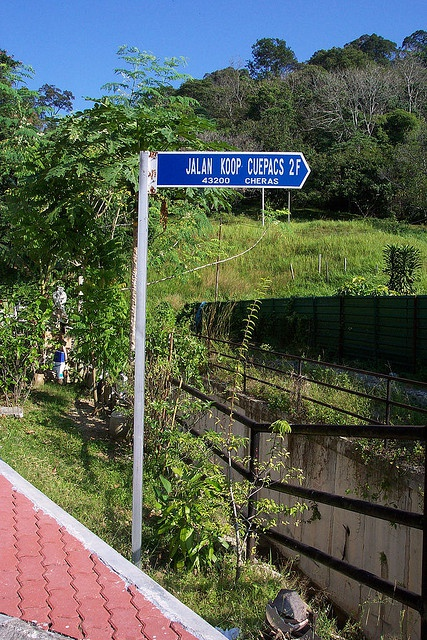Describe the objects in this image and their specific colors. I can see various objects in this image with different colors. 